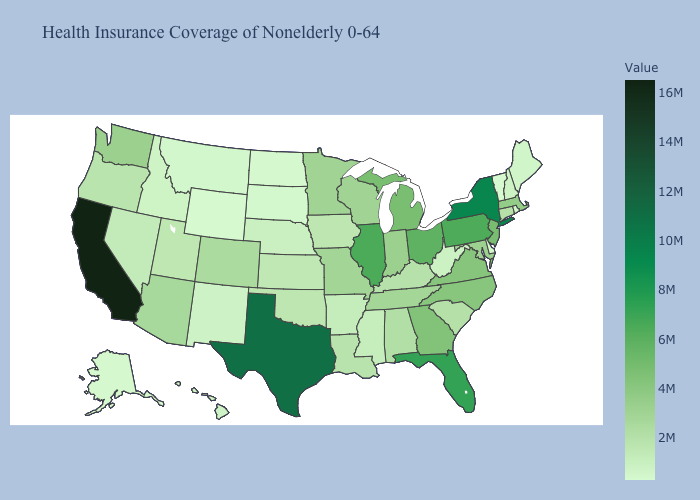Does Wisconsin have a higher value than Nevada?
Quick response, please. Yes. Which states hav the highest value in the Northeast?
Be succinct. New York. Which states hav the highest value in the MidWest?
Keep it brief. Illinois. Does Illinois have the highest value in the MidWest?
Concise answer only. Yes. Among the states that border Georgia , does South Carolina have the lowest value?
Short answer required. Yes. Which states have the lowest value in the West?
Answer briefly. Wyoming. 